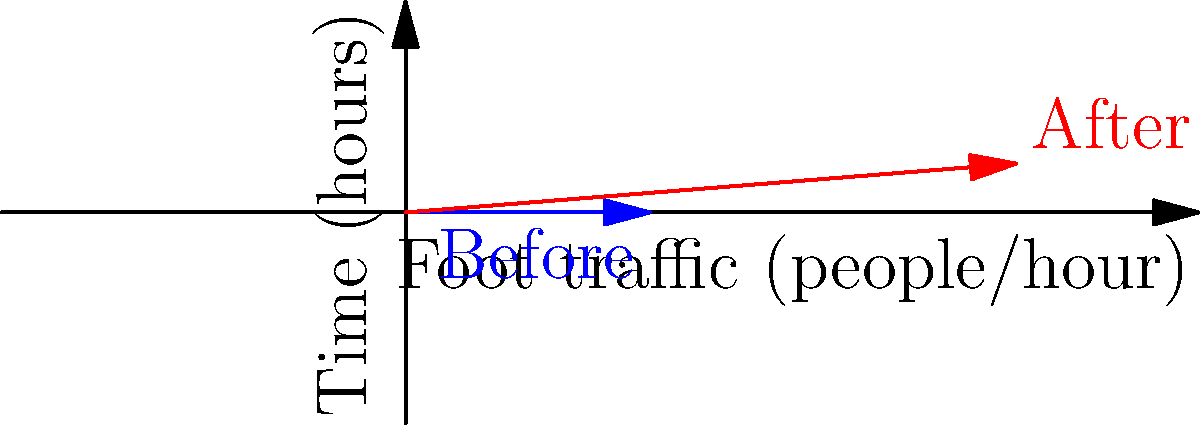The graph shows foot traffic in a neighborhood before and after street art installation. The blue vector represents the initial foot traffic, and the red vector represents the foot traffic after the installation. If each unit on the x-axis represents 10 people per hour and each unit on the y-axis represents 1 hour, calculate the increase in foot traffic per hour. To solve this problem, we need to follow these steps:

1. Identify the x-coordinates of both vectors:
   - Before (blue vector): $x_1 = 20$ units
   - After (red vector): $x_2 = 50$ units

2. Convert the x-coordinates to actual foot traffic:
   - Before: $20 \times 10 = 200$ people/hour
   - After: $50 \times 10 = 500$ people/hour

3. Calculate the increase in foot traffic:
   $\text{Increase} = \text{After} - \text{Before}$
   $\text{Increase} = 500 - 200 = 300$ people/hour

Therefore, the increase in foot traffic after the street art installation is 300 people per hour.
Answer: 300 people/hour 